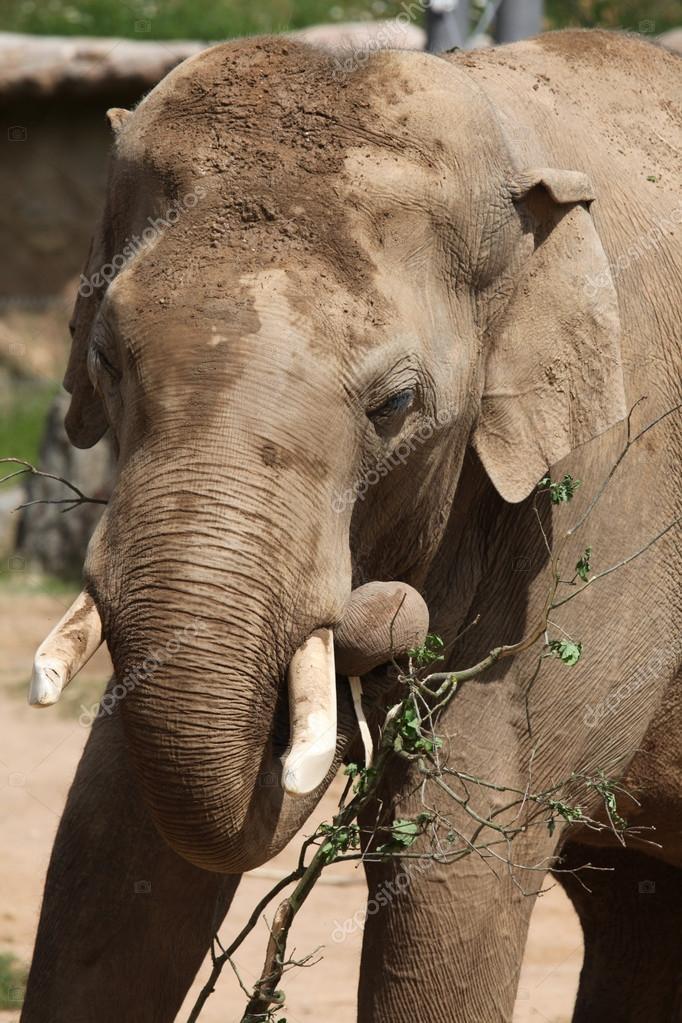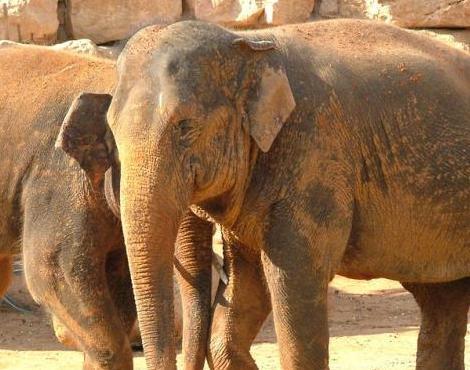The first image is the image on the left, the second image is the image on the right. Assess this claim about the two images: "Each image shows a single elephant, and all elephants have tusks.". Correct or not? Answer yes or no. No. The first image is the image on the left, the second image is the image on the right. Given the left and right images, does the statement "At least one of the elephants does not have tusks." hold true? Answer yes or no. Yes. 